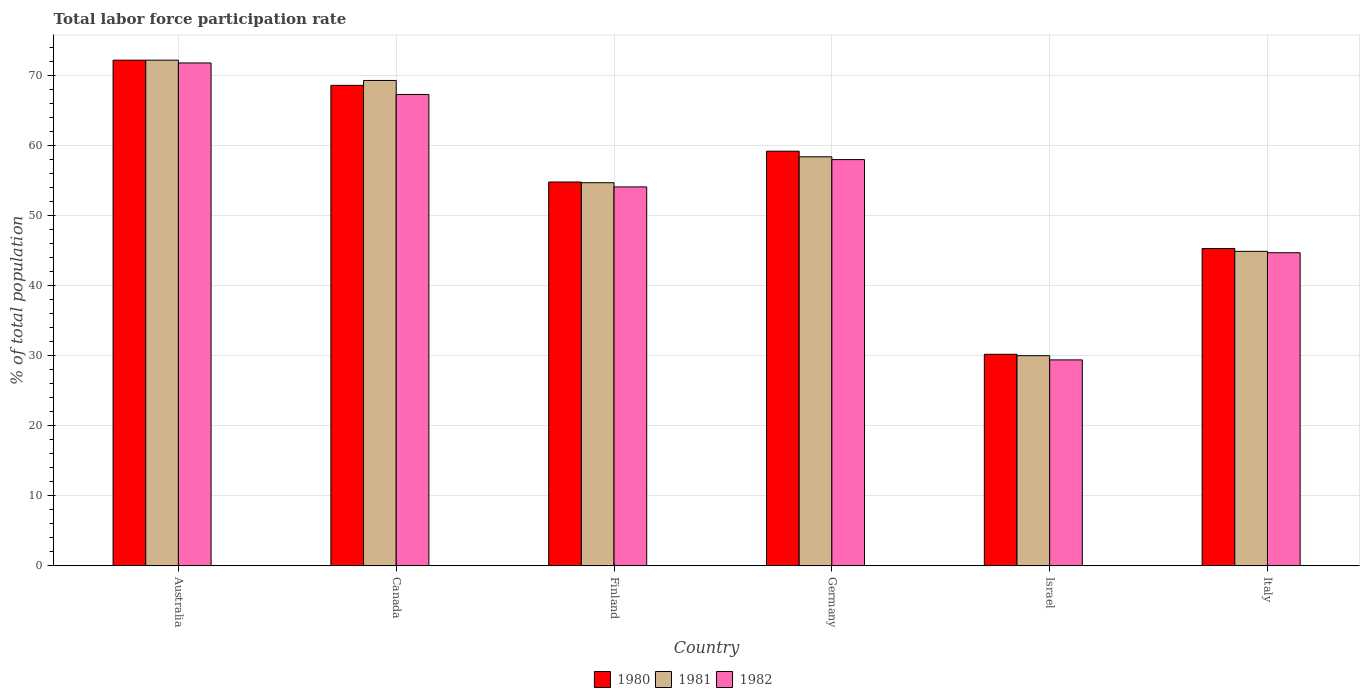How many different coloured bars are there?
Offer a very short reply. 3. How many groups of bars are there?
Offer a terse response. 6. Are the number of bars per tick equal to the number of legend labels?
Provide a short and direct response. Yes. How many bars are there on the 5th tick from the right?
Provide a short and direct response. 3. What is the label of the 1st group of bars from the left?
Ensure brevity in your answer.  Australia. What is the total labor force participation rate in 1980 in Israel?
Offer a very short reply. 30.2. Across all countries, what is the maximum total labor force participation rate in 1980?
Provide a short and direct response. 72.2. Across all countries, what is the minimum total labor force participation rate in 1980?
Give a very brief answer. 30.2. In which country was the total labor force participation rate in 1981 maximum?
Your answer should be very brief. Australia. What is the total total labor force participation rate in 1981 in the graph?
Ensure brevity in your answer.  329.5. What is the difference between the total labor force participation rate in 1981 in Australia and that in Finland?
Offer a terse response. 17.5. What is the difference between the total labor force participation rate in 1981 in Germany and the total labor force participation rate in 1982 in Australia?
Your answer should be compact. -13.4. What is the average total labor force participation rate in 1981 per country?
Provide a short and direct response. 54.92. What is the difference between the total labor force participation rate of/in 1980 and total labor force participation rate of/in 1982 in Germany?
Provide a succinct answer. 1.2. In how many countries, is the total labor force participation rate in 1981 greater than 46 %?
Keep it short and to the point. 4. What is the ratio of the total labor force participation rate in 1981 in Canada to that in Italy?
Provide a short and direct response. 1.54. Is the total labor force participation rate in 1981 in Canada less than that in Italy?
Your answer should be compact. No. What is the difference between the highest and the second highest total labor force participation rate in 1981?
Keep it short and to the point. 13.8. What is the difference between the highest and the lowest total labor force participation rate in 1981?
Your answer should be very brief. 42.2. What does the 2nd bar from the right in Canada represents?
Provide a short and direct response. 1981. How many bars are there?
Provide a succinct answer. 18. Are all the bars in the graph horizontal?
Your response must be concise. No. Are the values on the major ticks of Y-axis written in scientific E-notation?
Your answer should be compact. No. Where does the legend appear in the graph?
Keep it short and to the point. Bottom center. How many legend labels are there?
Offer a very short reply. 3. What is the title of the graph?
Offer a very short reply. Total labor force participation rate. Does "1988" appear as one of the legend labels in the graph?
Ensure brevity in your answer.  No. What is the label or title of the Y-axis?
Provide a short and direct response. % of total population. What is the % of total population in 1980 in Australia?
Your answer should be very brief. 72.2. What is the % of total population of 1981 in Australia?
Provide a short and direct response. 72.2. What is the % of total population of 1982 in Australia?
Provide a short and direct response. 71.8. What is the % of total population of 1980 in Canada?
Your response must be concise. 68.6. What is the % of total population of 1981 in Canada?
Your answer should be compact. 69.3. What is the % of total population in 1982 in Canada?
Give a very brief answer. 67.3. What is the % of total population of 1980 in Finland?
Your answer should be very brief. 54.8. What is the % of total population of 1981 in Finland?
Your answer should be compact. 54.7. What is the % of total population of 1982 in Finland?
Your answer should be compact. 54.1. What is the % of total population in 1980 in Germany?
Your answer should be compact. 59.2. What is the % of total population in 1981 in Germany?
Ensure brevity in your answer.  58.4. What is the % of total population of 1980 in Israel?
Ensure brevity in your answer.  30.2. What is the % of total population of 1981 in Israel?
Your response must be concise. 30. What is the % of total population in 1982 in Israel?
Keep it short and to the point. 29.4. What is the % of total population of 1980 in Italy?
Provide a succinct answer. 45.3. What is the % of total population in 1981 in Italy?
Make the answer very short. 44.9. What is the % of total population in 1982 in Italy?
Give a very brief answer. 44.7. Across all countries, what is the maximum % of total population of 1980?
Keep it short and to the point. 72.2. Across all countries, what is the maximum % of total population in 1981?
Offer a terse response. 72.2. Across all countries, what is the maximum % of total population in 1982?
Ensure brevity in your answer.  71.8. Across all countries, what is the minimum % of total population of 1980?
Give a very brief answer. 30.2. Across all countries, what is the minimum % of total population of 1981?
Your answer should be compact. 30. Across all countries, what is the minimum % of total population of 1982?
Provide a succinct answer. 29.4. What is the total % of total population in 1980 in the graph?
Your answer should be very brief. 330.3. What is the total % of total population in 1981 in the graph?
Your answer should be very brief. 329.5. What is the total % of total population of 1982 in the graph?
Keep it short and to the point. 325.3. What is the difference between the % of total population in 1981 in Australia and that in Canada?
Give a very brief answer. 2.9. What is the difference between the % of total population of 1982 in Australia and that in Canada?
Ensure brevity in your answer.  4.5. What is the difference between the % of total population of 1981 in Australia and that in Finland?
Provide a succinct answer. 17.5. What is the difference between the % of total population of 1982 in Australia and that in Finland?
Offer a terse response. 17.7. What is the difference between the % of total population in 1981 in Australia and that in Israel?
Provide a succinct answer. 42.2. What is the difference between the % of total population of 1982 in Australia and that in Israel?
Your answer should be very brief. 42.4. What is the difference between the % of total population in 1980 in Australia and that in Italy?
Give a very brief answer. 26.9. What is the difference between the % of total population in 1981 in Australia and that in Italy?
Your answer should be very brief. 27.3. What is the difference between the % of total population in 1982 in Australia and that in Italy?
Offer a terse response. 27.1. What is the difference between the % of total population of 1981 in Canada and that in Finland?
Keep it short and to the point. 14.6. What is the difference between the % of total population of 1982 in Canada and that in Finland?
Your answer should be compact. 13.2. What is the difference between the % of total population of 1980 in Canada and that in Germany?
Provide a short and direct response. 9.4. What is the difference between the % of total population of 1980 in Canada and that in Israel?
Your response must be concise. 38.4. What is the difference between the % of total population of 1981 in Canada and that in Israel?
Provide a succinct answer. 39.3. What is the difference between the % of total population of 1982 in Canada and that in Israel?
Provide a short and direct response. 37.9. What is the difference between the % of total population in 1980 in Canada and that in Italy?
Offer a terse response. 23.3. What is the difference between the % of total population in 1981 in Canada and that in Italy?
Your response must be concise. 24.4. What is the difference between the % of total population of 1982 in Canada and that in Italy?
Your answer should be very brief. 22.6. What is the difference between the % of total population in 1981 in Finland and that in Germany?
Offer a very short reply. -3.7. What is the difference between the % of total population in 1982 in Finland and that in Germany?
Your answer should be compact. -3.9. What is the difference between the % of total population in 1980 in Finland and that in Israel?
Your response must be concise. 24.6. What is the difference between the % of total population of 1981 in Finland and that in Israel?
Your answer should be very brief. 24.7. What is the difference between the % of total population in 1982 in Finland and that in Israel?
Your answer should be compact. 24.7. What is the difference between the % of total population in 1982 in Finland and that in Italy?
Give a very brief answer. 9.4. What is the difference between the % of total population in 1980 in Germany and that in Israel?
Provide a short and direct response. 29. What is the difference between the % of total population in 1981 in Germany and that in Israel?
Ensure brevity in your answer.  28.4. What is the difference between the % of total population of 1982 in Germany and that in Israel?
Offer a very short reply. 28.6. What is the difference between the % of total population in 1980 in Germany and that in Italy?
Give a very brief answer. 13.9. What is the difference between the % of total population of 1981 in Germany and that in Italy?
Offer a very short reply. 13.5. What is the difference between the % of total population in 1980 in Israel and that in Italy?
Provide a succinct answer. -15.1. What is the difference between the % of total population of 1981 in Israel and that in Italy?
Give a very brief answer. -14.9. What is the difference between the % of total population of 1982 in Israel and that in Italy?
Your answer should be very brief. -15.3. What is the difference between the % of total population in 1980 in Australia and the % of total population in 1981 in Canada?
Your response must be concise. 2.9. What is the difference between the % of total population in 1980 in Australia and the % of total population in 1982 in Canada?
Your answer should be compact. 4.9. What is the difference between the % of total population in 1981 in Australia and the % of total population in 1982 in Finland?
Provide a short and direct response. 18.1. What is the difference between the % of total population in 1980 in Australia and the % of total population in 1981 in Germany?
Give a very brief answer. 13.8. What is the difference between the % of total population in 1980 in Australia and the % of total population in 1981 in Israel?
Provide a succinct answer. 42.2. What is the difference between the % of total population of 1980 in Australia and the % of total population of 1982 in Israel?
Ensure brevity in your answer.  42.8. What is the difference between the % of total population of 1981 in Australia and the % of total population of 1982 in Israel?
Offer a very short reply. 42.8. What is the difference between the % of total population of 1980 in Australia and the % of total population of 1981 in Italy?
Provide a succinct answer. 27.3. What is the difference between the % of total population in 1980 in Australia and the % of total population in 1982 in Italy?
Keep it short and to the point. 27.5. What is the difference between the % of total population in 1981 in Australia and the % of total population in 1982 in Italy?
Offer a very short reply. 27.5. What is the difference between the % of total population of 1980 in Canada and the % of total population of 1982 in Finland?
Offer a terse response. 14.5. What is the difference between the % of total population of 1981 in Canada and the % of total population of 1982 in Finland?
Give a very brief answer. 15.2. What is the difference between the % of total population in 1980 in Canada and the % of total population in 1981 in Israel?
Your answer should be compact. 38.6. What is the difference between the % of total population in 1980 in Canada and the % of total population in 1982 in Israel?
Make the answer very short. 39.2. What is the difference between the % of total population in 1981 in Canada and the % of total population in 1982 in Israel?
Provide a short and direct response. 39.9. What is the difference between the % of total population of 1980 in Canada and the % of total population of 1981 in Italy?
Your answer should be very brief. 23.7. What is the difference between the % of total population in 1980 in Canada and the % of total population in 1982 in Italy?
Offer a terse response. 23.9. What is the difference between the % of total population of 1981 in Canada and the % of total population of 1982 in Italy?
Ensure brevity in your answer.  24.6. What is the difference between the % of total population of 1980 in Finland and the % of total population of 1982 in Germany?
Your answer should be very brief. -3.2. What is the difference between the % of total population in 1981 in Finland and the % of total population in 1982 in Germany?
Your response must be concise. -3.3. What is the difference between the % of total population in 1980 in Finland and the % of total population in 1981 in Israel?
Your answer should be very brief. 24.8. What is the difference between the % of total population of 1980 in Finland and the % of total population of 1982 in Israel?
Give a very brief answer. 25.4. What is the difference between the % of total population of 1981 in Finland and the % of total population of 1982 in Israel?
Provide a succinct answer. 25.3. What is the difference between the % of total population of 1980 in Finland and the % of total population of 1981 in Italy?
Offer a very short reply. 9.9. What is the difference between the % of total population in 1980 in Finland and the % of total population in 1982 in Italy?
Your answer should be very brief. 10.1. What is the difference between the % of total population in 1981 in Finland and the % of total population in 1982 in Italy?
Make the answer very short. 10. What is the difference between the % of total population of 1980 in Germany and the % of total population of 1981 in Israel?
Offer a very short reply. 29.2. What is the difference between the % of total population of 1980 in Germany and the % of total population of 1982 in Israel?
Your answer should be very brief. 29.8. What is the difference between the % of total population of 1980 in Germany and the % of total population of 1981 in Italy?
Your answer should be very brief. 14.3. What is the difference between the % of total population of 1980 in Israel and the % of total population of 1981 in Italy?
Offer a very short reply. -14.7. What is the difference between the % of total population of 1980 in Israel and the % of total population of 1982 in Italy?
Make the answer very short. -14.5. What is the difference between the % of total population of 1981 in Israel and the % of total population of 1982 in Italy?
Your answer should be very brief. -14.7. What is the average % of total population of 1980 per country?
Offer a terse response. 55.05. What is the average % of total population of 1981 per country?
Offer a terse response. 54.92. What is the average % of total population in 1982 per country?
Your response must be concise. 54.22. What is the difference between the % of total population of 1980 and % of total population of 1981 in Australia?
Provide a succinct answer. 0. What is the difference between the % of total population of 1981 and % of total population of 1982 in Australia?
Make the answer very short. 0.4. What is the difference between the % of total population of 1980 and % of total population of 1982 in Canada?
Your response must be concise. 1.3. What is the difference between the % of total population of 1980 and % of total population of 1982 in Finland?
Keep it short and to the point. 0.7. What is the difference between the % of total population of 1980 and % of total population of 1981 in Germany?
Your answer should be very brief. 0.8. What is the difference between the % of total population of 1981 and % of total population of 1982 in Germany?
Your response must be concise. 0.4. What is the difference between the % of total population of 1980 and % of total population of 1982 in Israel?
Provide a short and direct response. 0.8. What is the difference between the % of total population of 1981 and % of total population of 1982 in Israel?
Ensure brevity in your answer.  0.6. What is the ratio of the % of total population of 1980 in Australia to that in Canada?
Offer a terse response. 1.05. What is the ratio of the % of total population in 1981 in Australia to that in Canada?
Offer a very short reply. 1.04. What is the ratio of the % of total population of 1982 in Australia to that in Canada?
Give a very brief answer. 1.07. What is the ratio of the % of total population of 1980 in Australia to that in Finland?
Provide a short and direct response. 1.32. What is the ratio of the % of total population in 1981 in Australia to that in Finland?
Ensure brevity in your answer.  1.32. What is the ratio of the % of total population in 1982 in Australia to that in Finland?
Keep it short and to the point. 1.33. What is the ratio of the % of total population in 1980 in Australia to that in Germany?
Make the answer very short. 1.22. What is the ratio of the % of total population in 1981 in Australia to that in Germany?
Provide a succinct answer. 1.24. What is the ratio of the % of total population of 1982 in Australia to that in Germany?
Your answer should be very brief. 1.24. What is the ratio of the % of total population of 1980 in Australia to that in Israel?
Make the answer very short. 2.39. What is the ratio of the % of total population of 1981 in Australia to that in Israel?
Your answer should be very brief. 2.41. What is the ratio of the % of total population in 1982 in Australia to that in Israel?
Ensure brevity in your answer.  2.44. What is the ratio of the % of total population of 1980 in Australia to that in Italy?
Provide a succinct answer. 1.59. What is the ratio of the % of total population of 1981 in Australia to that in Italy?
Keep it short and to the point. 1.61. What is the ratio of the % of total population in 1982 in Australia to that in Italy?
Make the answer very short. 1.61. What is the ratio of the % of total population of 1980 in Canada to that in Finland?
Provide a short and direct response. 1.25. What is the ratio of the % of total population of 1981 in Canada to that in Finland?
Your answer should be very brief. 1.27. What is the ratio of the % of total population in 1982 in Canada to that in Finland?
Provide a succinct answer. 1.24. What is the ratio of the % of total population in 1980 in Canada to that in Germany?
Your answer should be very brief. 1.16. What is the ratio of the % of total population of 1981 in Canada to that in Germany?
Provide a succinct answer. 1.19. What is the ratio of the % of total population in 1982 in Canada to that in Germany?
Offer a terse response. 1.16. What is the ratio of the % of total population in 1980 in Canada to that in Israel?
Ensure brevity in your answer.  2.27. What is the ratio of the % of total population in 1981 in Canada to that in Israel?
Ensure brevity in your answer.  2.31. What is the ratio of the % of total population of 1982 in Canada to that in Israel?
Your answer should be very brief. 2.29. What is the ratio of the % of total population of 1980 in Canada to that in Italy?
Your response must be concise. 1.51. What is the ratio of the % of total population of 1981 in Canada to that in Italy?
Your answer should be very brief. 1.54. What is the ratio of the % of total population of 1982 in Canada to that in Italy?
Give a very brief answer. 1.51. What is the ratio of the % of total population of 1980 in Finland to that in Germany?
Keep it short and to the point. 0.93. What is the ratio of the % of total population in 1981 in Finland to that in Germany?
Give a very brief answer. 0.94. What is the ratio of the % of total population in 1982 in Finland to that in Germany?
Your answer should be compact. 0.93. What is the ratio of the % of total population of 1980 in Finland to that in Israel?
Your answer should be compact. 1.81. What is the ratio of the % of total population in 1981 in Finland to that in Israel?
Provide a succinct answer. 1.82. What is the ratio of the % of total population in 1982 in Finland to that in Israel?
Your answer should be very brief. 1.84. What is the ratio of the % of total population of 1980 in Finland to that in Italy?
Your answer should be compact. 1.21. What is the ratio of the % of total population of 1981 in Finland to that in Italy?
Ensure brevity in your answer.  1.22. What is the ratio of the % of total population of 1982 in Finland to that in Italy?
Keep it short and to the point. 1.21. What is the ratio of the % of total population in 1980 in Germany to that in Israel?
Offer a very short reply. 1.96. What is the ratio of the % of total population of 1981 in Germany to that in Israel?
Your answer should be compact. 1.95. What is the ratio of the % of total population of 1982 in Germany to that in Israel?
Your answer should be compact. 1.97. What is the ratio of the % of total population in 1980 in Germany to that in Italy?
Provide a short and direct response. 1.31. What is the ratio of the % of total population of 1981 in Germany to that in Italy?
Keep it short and to the point. 1.3. What is the ratio of the % of total population in 1982 in Germany to that in Italy?
Keep it short and to the point. 1.3. What is the ratio of the % of total population of 1981 in Israel to that in Italy?
Offer a very short reply. 0.67. What is the ratio of the % of total population in 1982 in Israel to that in Italy?
Your response must be concise. 0.66. What is the difference between the highest and the second highest % of total population of 1981?
Your answer should be very brief. 2.9. What is the difference between the highest and the lowest % of total population of 1981?
Your answer should be very brief. 42.2. What is the difference between the highest and the lowest % of total population of 1982?
Your answer should be compact. 42.4. 